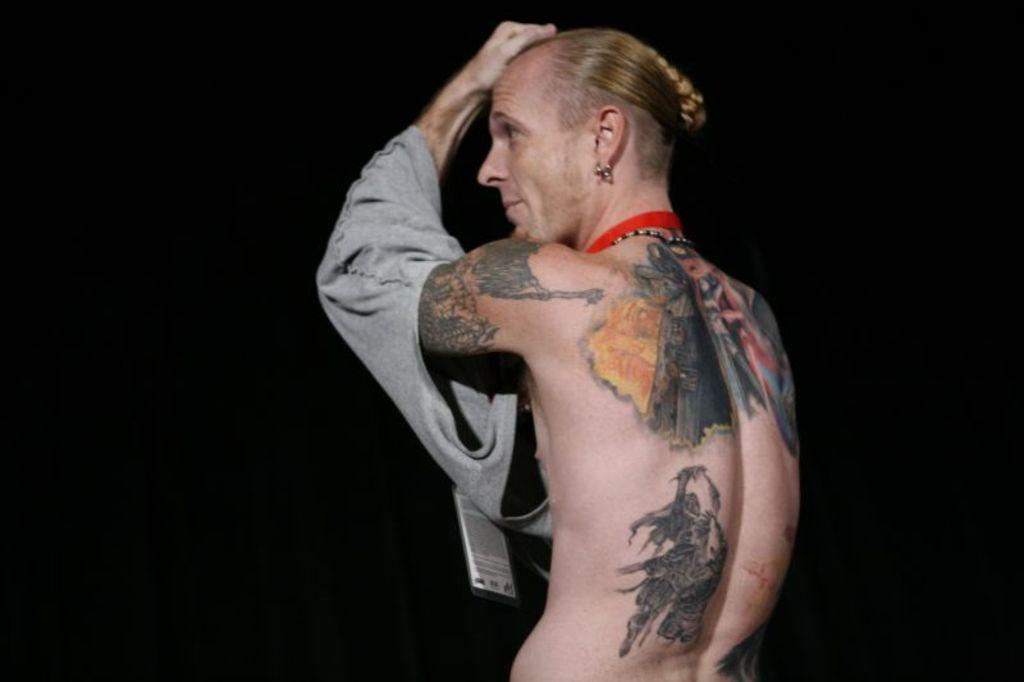What is the main subject of the image? There is a person in the image. Can you describe any distinguishing features of the person? The person has several tattoos. What type of orange is the person holding in the image? There is no orange present in the image; the person has several tattoos. What medical advice is the person seeking from the doctor in the image? There is no doctor present in the image, and no indication of any medical advice being sought. 